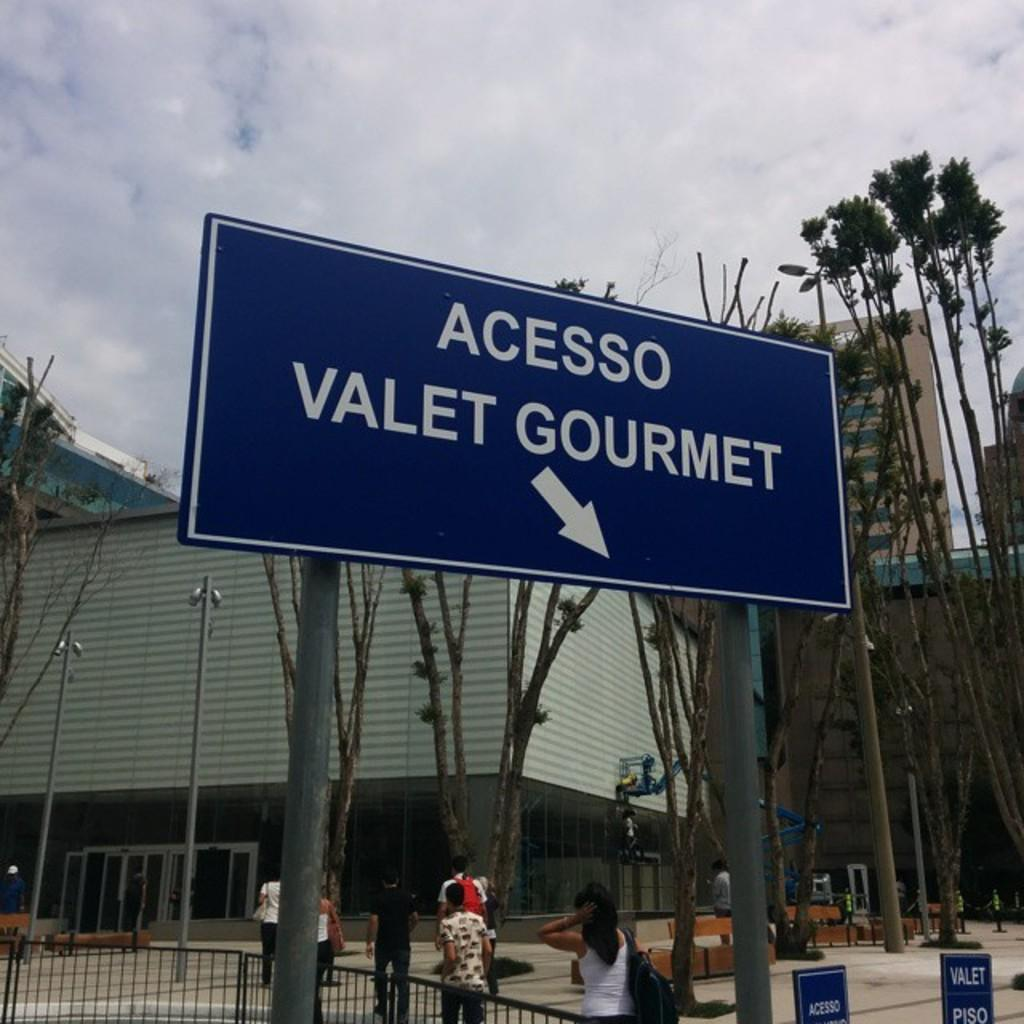<image>
Describe the image concisely. A sign indicating Accesso Valet Gourmet with an arrow pointing down and to the right. 